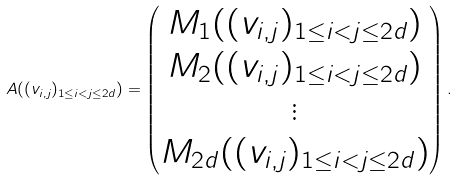Convert formula to latex. <formula><loc_0><loc_0><loc_500><loc_500>A ( ( v _ { i , j } ) _ { 1 \leq i < j \leq 2 d } ) = \begin{pmatrix} M _ { 1 } ( ( v _ { i , j } ) _ { 1 \leq i < j \leq 2 d } ) \\ M _ { 2 } ( ( v _ { i , j } ) _ { 1 \leq i < j \leq 2 d } ) \\ \vdots \\ M _ { 2 d } ( ( v _ { i , j } ) _ { 1 \leq i < j \leq 2 d } ) \\ \end{pmatrix} .</formula> 